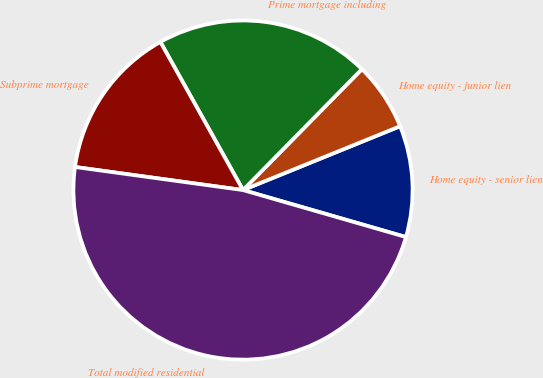Convert chart. <chart><loc_0><loc_0><loc_500><loc_500><pie_chart><fcel>Home equity - senior lien<fcel>Home equity - junior lien<fcel>Prime mortgage including<fcel>Subprime mortgage<fcel>Total modified residential<nl><fcel>10.61%<fcel>6.49%<fcel>20.46%<fcel>14.73%<fcel>47.7%<nl></chart> 